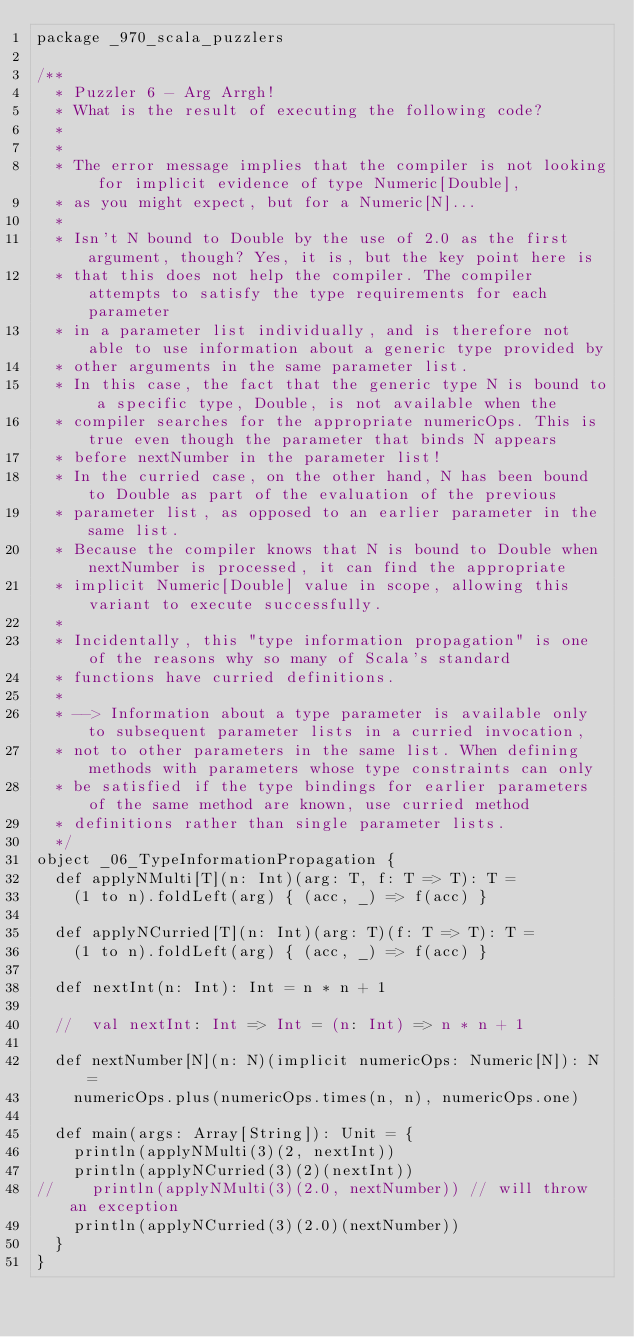<code> <loc_0><loc_0><loc_500><loc_500><_Scala_>package _970_scala_puzzlers

/**
  * Puzzler 6 - Arg Arrgh!
  * What is the result of executing the following code?
  *
  *
  * The error message implies that the compiler is not looking for implicit evidence of type Numeric[Double],
  * as you might expect, but for a Numeric[N]...
  *
  * Isn't N bound to Double by the use of 2.0 as the first argument, though? Yes, it is, but the key point here is
  * that this does not help the compiler. The compiler attempts to satisfy the type requirements for each parameter
  * in a parameter list individually, and is therefore not able to use information about a generic type provided by
  * other arguments in the same parameter list.
  * In this case, the fact that the generic type N is bound to a specific type, Double, is not available when the
  * compiler searches for the appropriate numericOps. This is true even though the parameter that binds N appears
  * before nextNumber in the parameter list!
  * In the curried case, on the other hand, N has been bound to Double as part of the evaluation of the previous
  * parameter list, as opposed to an earlier parameter in the same list.
  * Because the compiler knows that N is bound to Double when nextNumber is processed, it can find the appropriate
  * implicit Numeric[Double] value in scope, allowing this variant to execute successfully.
  *
  * Incidentally, this "type information propagation" is one of the reasons why so many of Scala's standard
  * functions have curried definitions.
  *
  * --> Information about a type parameter is available only to subsequent parameter lists in a curried invocation,
  * not to other parameters in the same list. When defining methods with parameters whose type constraints can only
  * be satisfied if the type bindings for earlier parameters of the same method are known, use curried method
  * definitions rather than single parameter lists.
  */
object _06_TypeInformationPropagation {
  def applyNMulti[T](n: Int)(arg: T, f: T => T): T =
    (1 to n).foldLeft(arg) { (acc, _) => f(acc) }

  def applyNCurried[T](n: Int)(arg: T)(f: T => T): T =
    (1 to n).foldLeft(arg) { (acc, _) => f(acc) }

  def nextInt(n: Int): Int = n * n + 1

  //  val nextInt: Int => Int = (n: Int) => n * n + 1

  def nextNumber[N](n: N)(implicit numericOps: Numeric[N]): N =
    numericOps.plus(numericOps.times(n, n), numericOps.one)

  def main(args: Array[String]): Unit = {
    println(applyNMulti(3)(2, nextInt))
    println(applyNCurried(3)(2)(nextInt))
//    println(applyNMulti(3)(2.0, nextNumber)) // will throw an exception
    println(applyNCurried(3)(2.0)(nextNumber))
  }
}</code> 